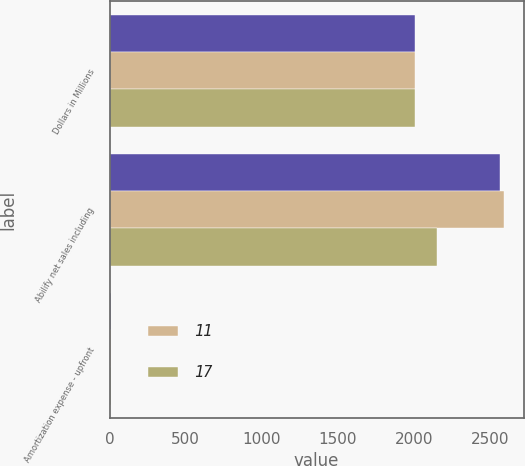Convert chart. <chart><loc_0><loc_0><loc_500><loc_500><stacked_bar_chart><ecel><fcel>Dollars in Millions<fcel>Abilify net sales including<fcel>Amortization expense - upfront<nl><fcel>nan<fcel>2010<fcel>2565<fcel>6<nl><fcel>11<fcel>2009<fcel>2592<fcel>6<nl><fcel>17<fcel>2008<fcel>2153<fcel>6<nl></chart> 